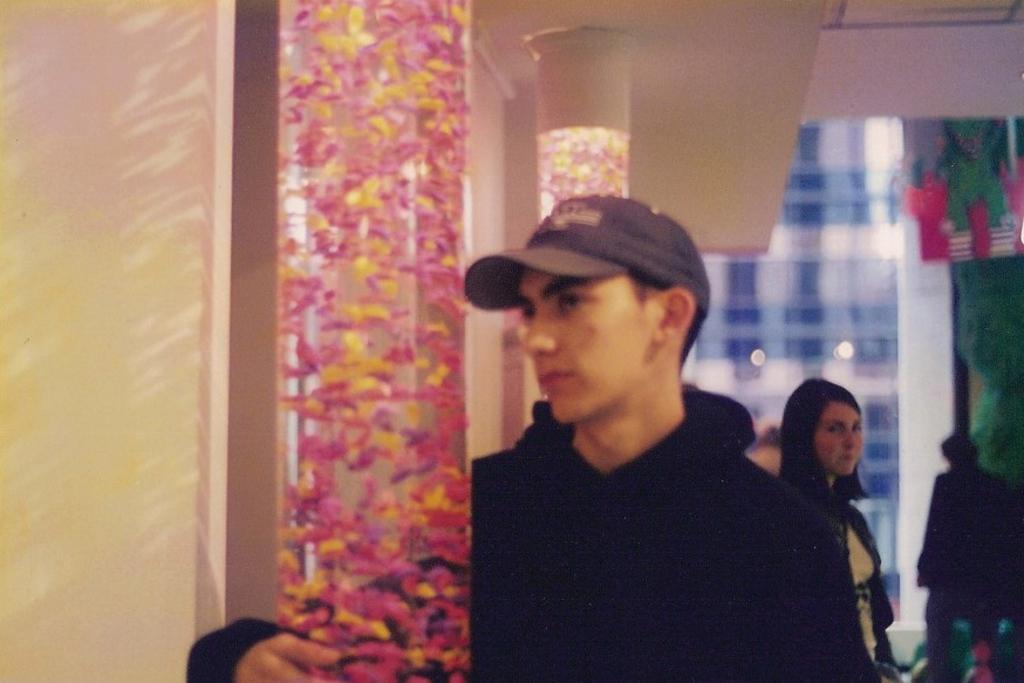In one or two sentences, can you explain what this image depicts? The man in front of the picture who is wearing the black jacket is standing beside the pillar. Behind him, we see a woman is standing. Behind her, we see a pillar. On the right side, we see a wall or a pillar in green color. Beside that, we see a man is standing. In the background, we see a building. On the left side, we see a wall in white color. 